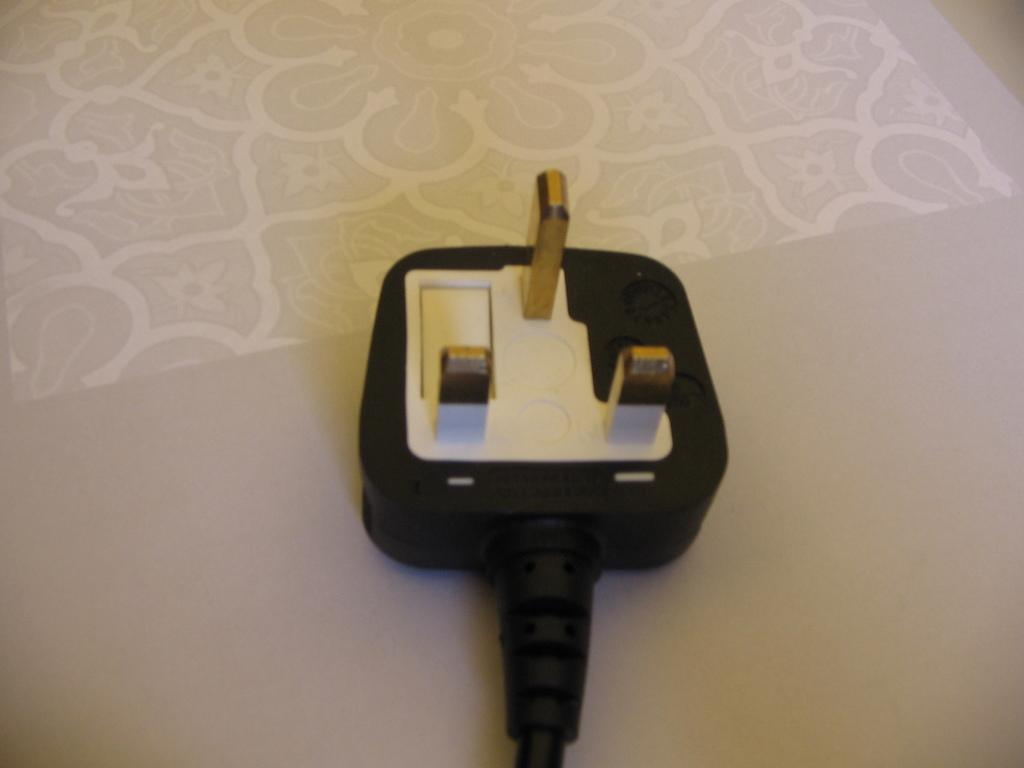What is the color of the surface in the image? The surface in the image is cream-colored. What can be seen on the surface? The surface has designs on it. What type of control is present on the surface? There is a switch on the surface. What is the color of the switch? The switch is black in color. How many pins does the switch have? The switch has three pins. How many rabbits are sitting on the cream-colored surface in the image? There are no rabbits present in the image; it only features a surface with a switch and designs. 